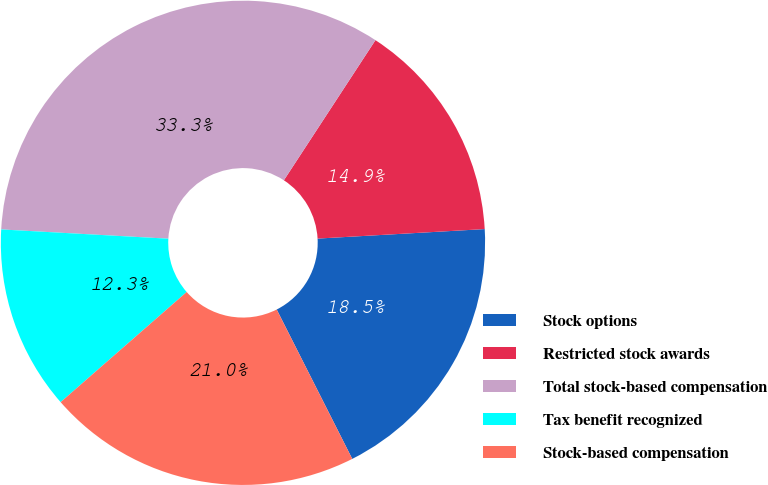Convert chart to OTSL. <chart><loc_0><loc_0><loc_500><loc_500><pie_chart><fcel>Stock options<fcel>Restricted stock awards<fcel>Total stock-based compensation<fcel>Tax benefit recognized<fcel>Stock-based compensation<nl><fcel>18.45%<fcel>14.88%<fcel>33.33%<fcel>12.31%<fcel>21.02%<nl></chart> 